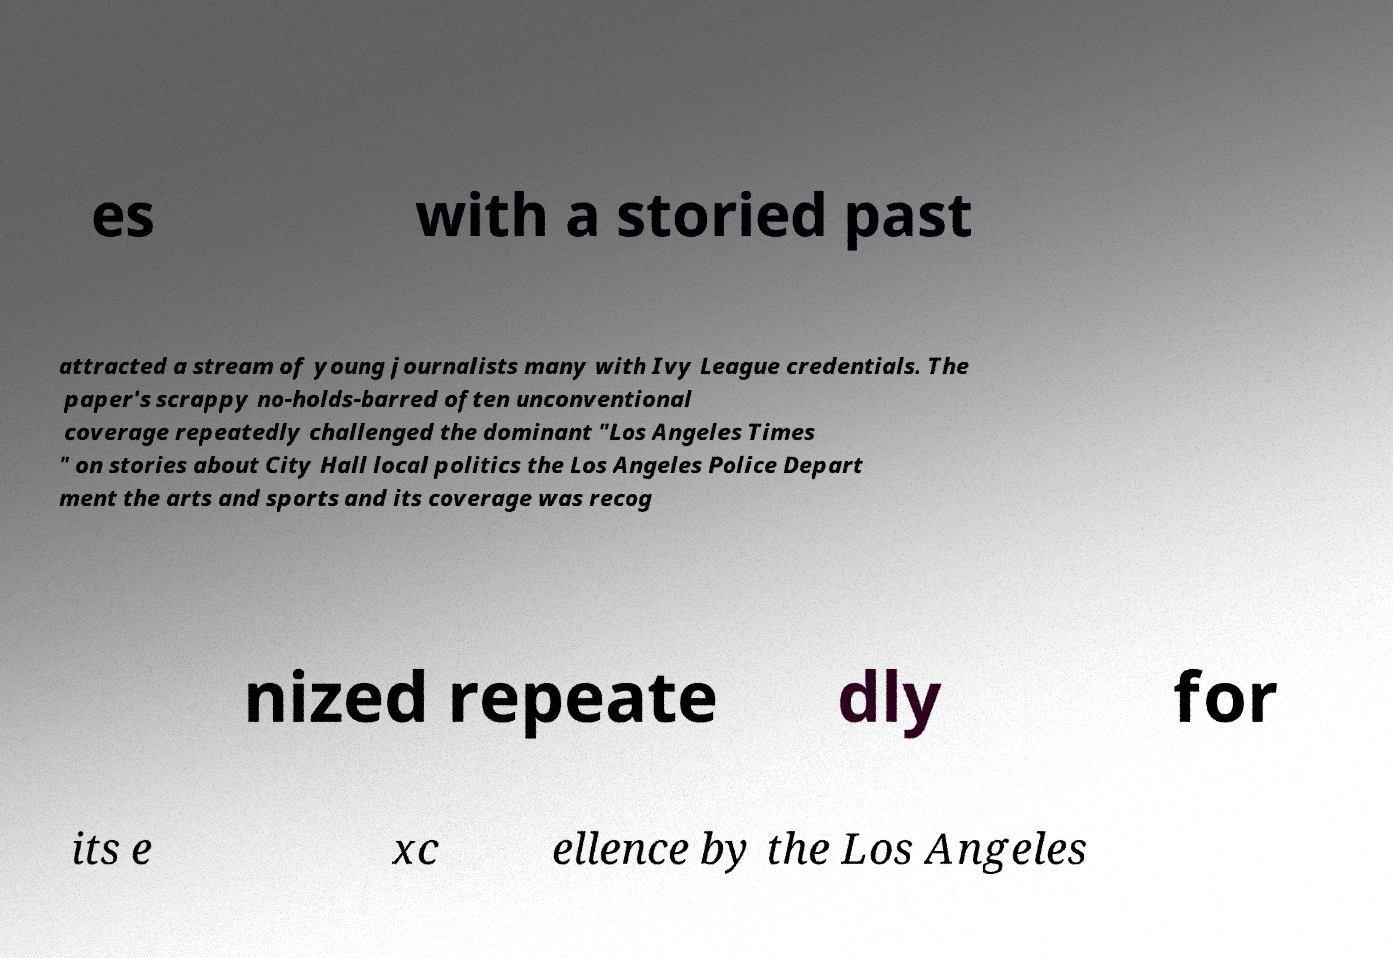Could you extract and type out the text from this image? es with a storied past attracted a stream of young journalists many with Ivy League credentials. The paper's scrappy no-holds-barred often unconventional coverage repeatedly challenged the dominant "Los Angeles Times " on stories about City Hall local politics the Los Angeles Police Depart ment the arts and sports and its coverage was recog nized repeate dly for its e xc ellence by the Los Angeles 